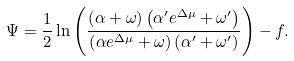<formula> <loc_0><loc_0><loc_500><loc_500>\Psi = \frac { 1 } { 2 } \ln \left ( \frac { \left ( \alpha + \omega \right ) \left ( \alpha ^ { \prime } e ^ { \Delta \mu } + \omega ^ { \prime } \right ) } { \left ( \alpha e ^ { \Delta \mu } + \omega \right ) \left ( \alpha ^ { \prime } + \omega ^ { \prime } \right ) } \right ) - f .</formula> 